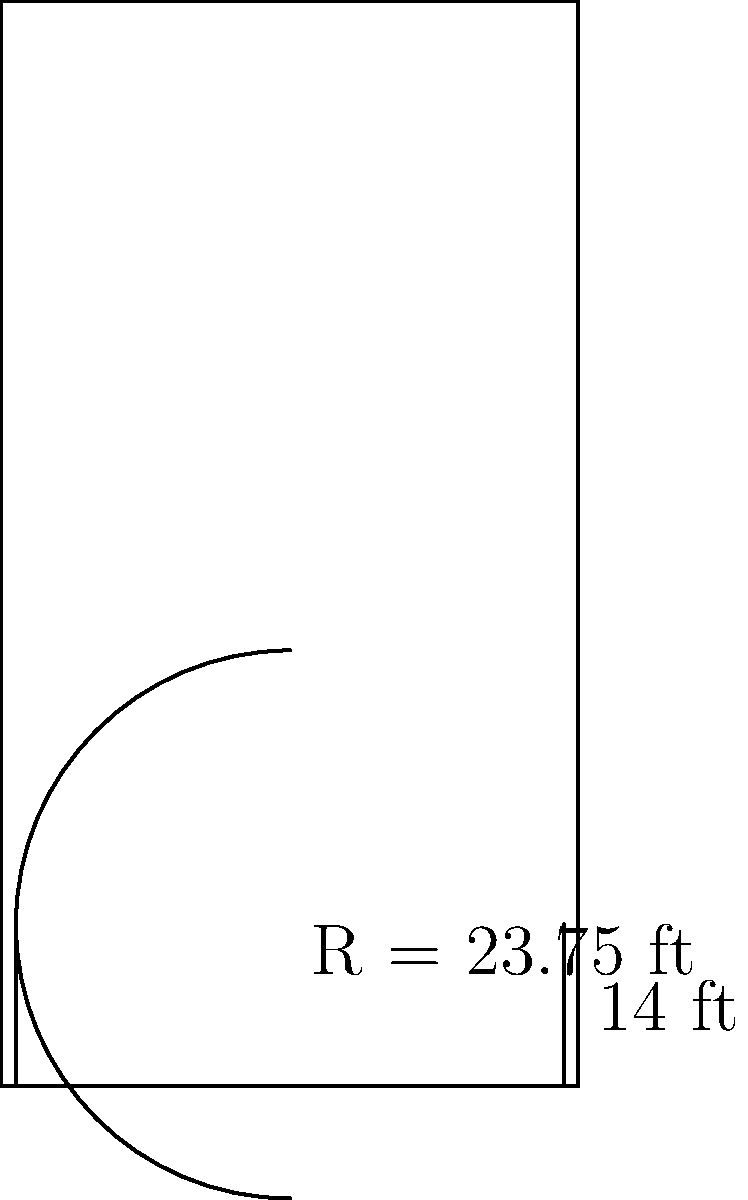As a member of the GSU basketball team, you're asked to calculate the area of the three-point zone on your home court. Given that the three-point line has a radius of 23.75 feet and extends straight for 14 feet on each side before curving, what is the total area of the three-point zone in square feet? Round your answer to the nearest whole number. To calculate the area of the three-point zone, we need to break it down into two parts:

1. The area of the circular sector
2. The area of the two rectangles on the sides

Step 1: Calculate the area of the circular sector
- The radius (r) of the three-point line is 23.75 feet
- The central angle (θ) of the sector can be found using the inverse sine function:
  $\theta = 2 \cdot \arcsin(\frac{14}{23.75}) \approx 2.0944$ radians
- Area of the sector: $A_{sector} = \frac{1}{2}r^2\theta$
  $A_{sector} = \frac{1}{2} \cdot 23.75^2 \cdot 2.0944 \approx 588.51$ sq ft

Step 2: Calculate the area of the two rectangles
- Each rectangle has a width of 14 feet and a length of (23.75 - 14) = 9.75 feet
- Area of both rectangles: $A_{rectangles} = 2 \cdot 14 \cdot 9.75 = 273$ sq ft

Step 3: Sum up the total area
Total Area = Area of sector + Area of rectangles
$A_{total} = 588.51 + 273 = 861.51$ sq ft

Step 4: Round to the nearest whole number
$861.51 \approx 862$ sq ft
Answer: 862 sq ft 